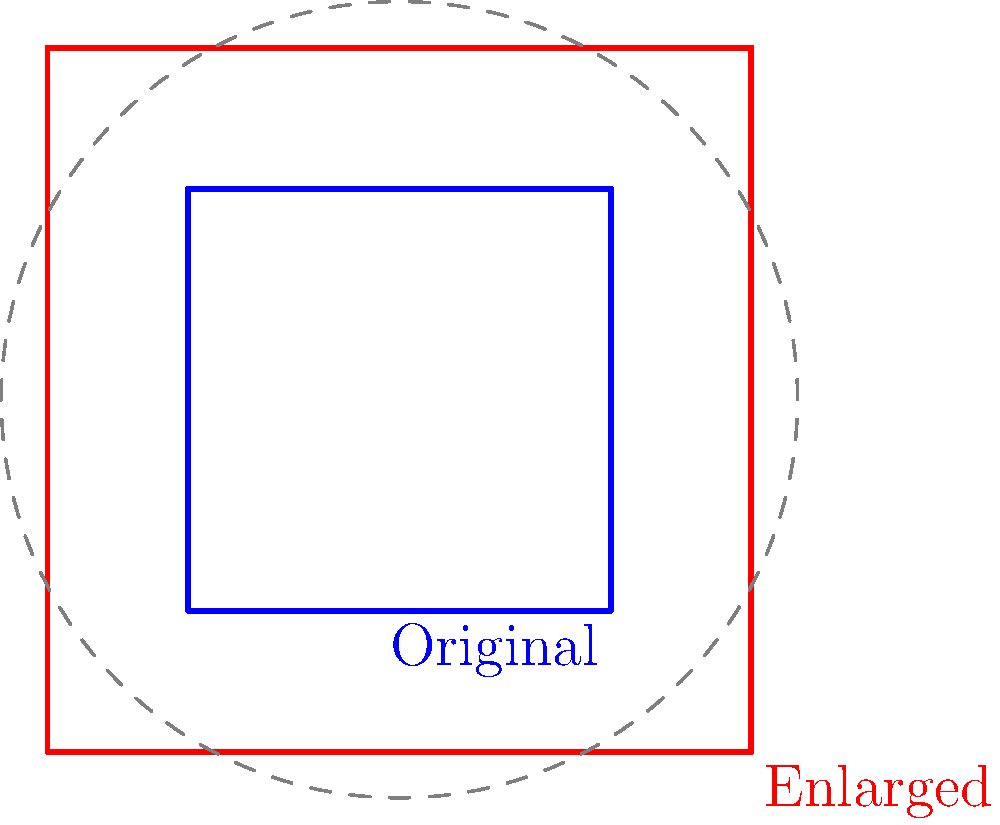You want to enlarge a cross-stitch pattern for your granddaughter's project. The original pattern fits in a 6-inch square, but you need it to fit in a 10-inch square. What scale factor should you use to enlarge the pattern? To find the scale factor, we need to compare the new size to the original size:

1. Original size: 6 inches
2. New size: 10 inches

The scale factor is calculated by dividing the new size by the original size:

$$ \text{Scale factor} = \frac{\text{New size}}{\text{Original size}} $$

$$ \text{Scale factor} = \frac{10 \text{ inches}}{6 \text{ inches}} $$

$$ \text{Scale factor} = \frac{10}{6} $$

$$ \text{Scale factor} = \frac{5}{3} \approx 1.67 $$

Therefore, you need to enlarge the pattern by a scale factor of $\frac{5}{3}$ or approximately 1.67 times its original size.
Answer: $\frac{5}{3}$ 